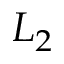Convert formula to latex. <formula><loc_0><loc_0><loc_500><loc_500>L _ { 2 }</formula> 